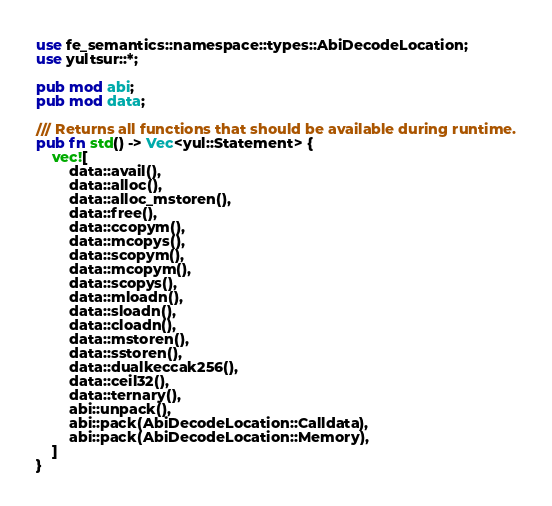Convert code to text. <code><loc_0><loc_0><loc_500><loc_500><_Rust_>use fe_semantics::namespace::types::AbiDecodeLocation;
use yultsur::*;

pub mod abi;
pub mod data;

/// Returns all functions that should be available during runtime.
pub fn std() -> Vec<yul::Statement> {
    vec![
        data::avail(),
        data::alloc(),
        data::alloc_mstoren(),
        data::free(),
        data::ccopym(),
        data::mcopys(),
        data::scopym(),
        data::mcopym(),
        data::scopys(),
        data::mloadn(),
        data::sloadn(),
        data::cloadn(),
        data::mstoren(),
        data::sstoren(),
        data::dualkeccak256(),
        data::ceil32(),
        data::ternary(),
        abi::unpack(),
        abi::pack(AbiDecodeLocation::Calldata),
        abi::pack(AbiDecodeLocation::Memory),
    ]
}
</code> 